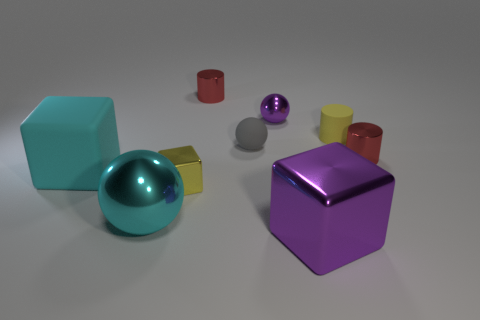Add 1 brown matte things. How many objects exist? 10 Subtract all purple shiny balls. How many balls are left? 2 Subtract 1 spheres. How many spheres are left? 2 Add 7 rubber objects. How many rubber objects are left? 10 Add 1 large purple things. How many large purple things exist? 2 Subtract all yellow cylinders. How many cylinders are left? 2 Subtract 0 cyan cylinders. How many objects are left? 9 Subtract all spheres. How many objects are left? 6 Subtract all brown cylinders. Subtract all gray blocks. How many cylinders are left? 3 Subtract all purple cubes. How many red cylinders are left? 2 